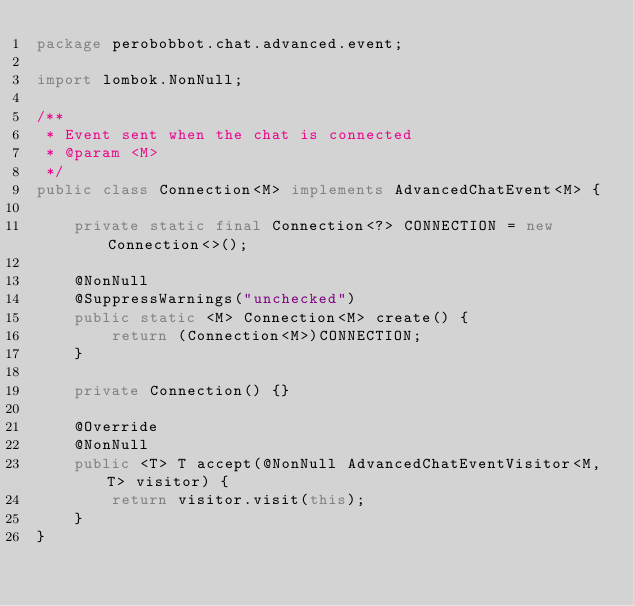<code> <loc_0><loc_0><loc_500><loc_500><_Java_>package perobobbot.chat.advanced.event;

import lombok.NonNull;

/**
 * Event sent when the chat is connected
 * @param <M>
 */
public class Connection<M> implements AdvancedChatEvent<M> {

    private static final Connection<?> CONNECTION = new Connection<>();

    @NonNull
    @SuppressWarnings("unchecked")
    public static <M> Connection<M> create() {
        return (Connection<M>)CONNECTION;
    }

    private Connection() {}

    @Override
    @NonNull
    public <T> T accept(@NonNull AdvancedChatEventVisitor<M,T> visitor) {
        return visitor.visit(this);
    }
}
</code> 